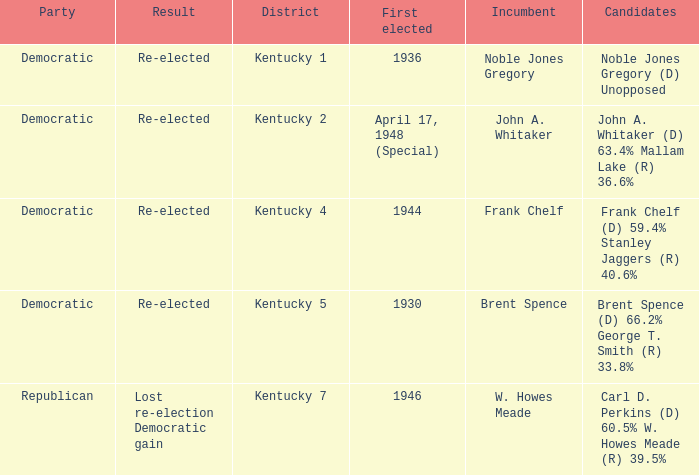Which party won in the election in voting district Kentucky 5? Democratic. 